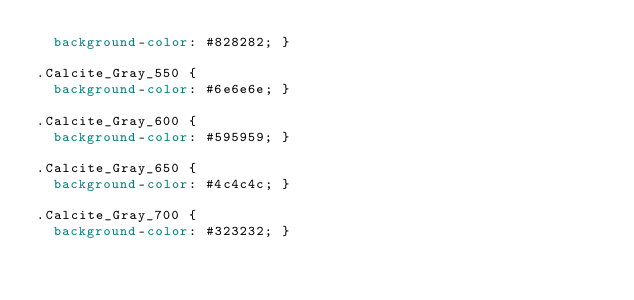Convert code to text. <code><loc_0><loc_0><loc_500><loc_500><_CSS_>  background-color: #828282; }

.Calcite_Gray_550 {
  background-color: #6e6e6e; }

.Calcite_Gray_600 {
  background-color: #595959; }

.Calcite_Gray_650 {
  background-color: #4c4c4c; }

.Calcite_Gray_700 {
  background-color: #323232; }


</code> 